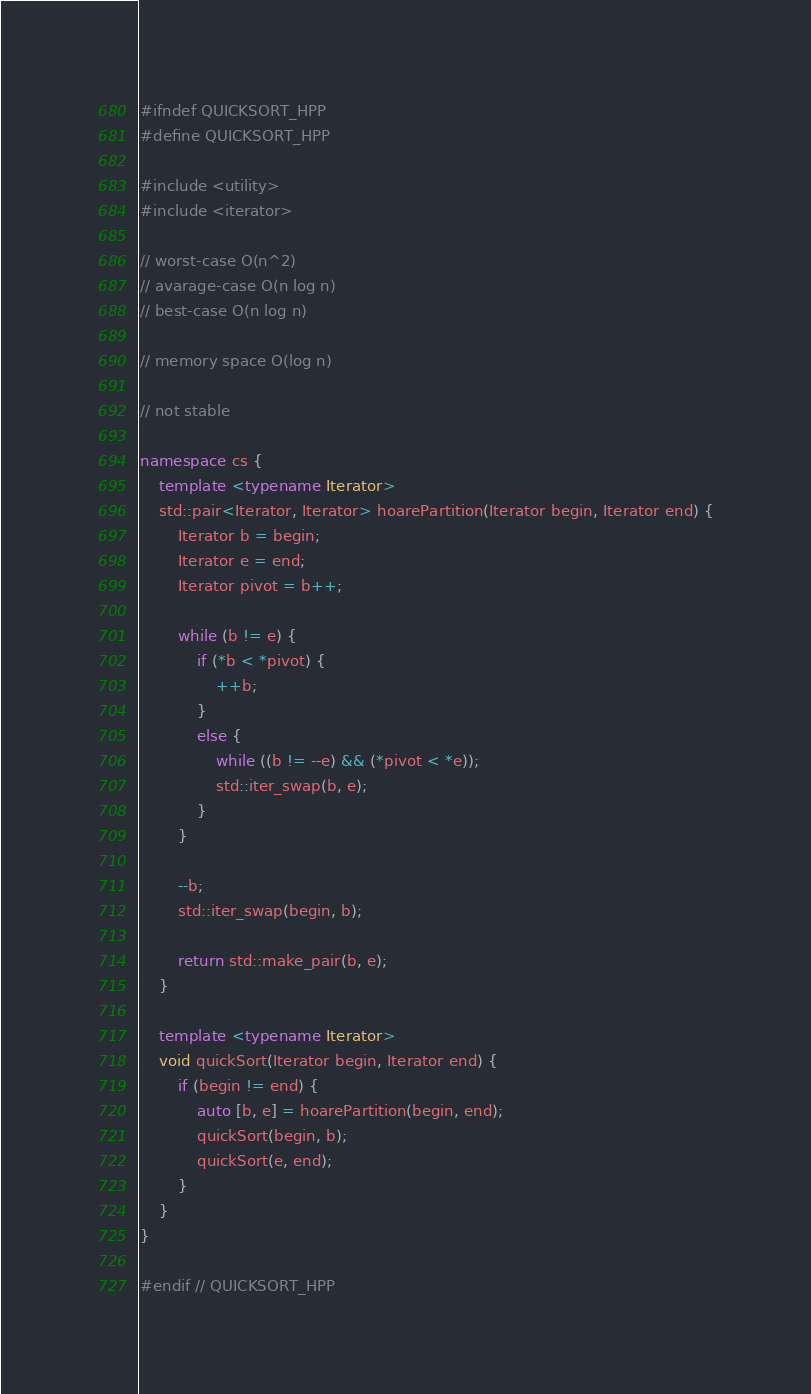Convert code to text. <code><loc_0><loc_0><loc_500><loc_500><_C++_>#ifndef QUICKSORT_HPP
#define QUICKSORT_HPP

#include <utility>
#include <iterator>

// worst-case O(n^2)
// avarage-case O(n log n)
// best-case O(n log n)

// memory space O(log n)

// not stable

namespace cs {
    template <typename Iterator>
    std::pair<Iterator, Iterator> hoarePartition(Iterator begin, Iterator end) {
        Iterator b = begin;
        Iterator e = end;
        Iterator pivot = b++;

        while (b != e) {
            if (*b < *pivot) {
                ++b;
            }
            else {
                while ((b != --e) && (*pivot < *e));
                std::iter_swap(b, e);
            }
        }

        --b;
        std::iter_swap(begin, b);

        return std::make_pair(b, e);
    }

    template <typename Iterator>
    void quickSort(Iterator begin, Iterator end) {
        if (begin != end) {
            auto [b, e] = hoarePartition(begin, end);
            quickSort(begin, b);
            quickSort(e, end);
        }
    }
}

#endif // QUICKSORT_HPP
</code> 